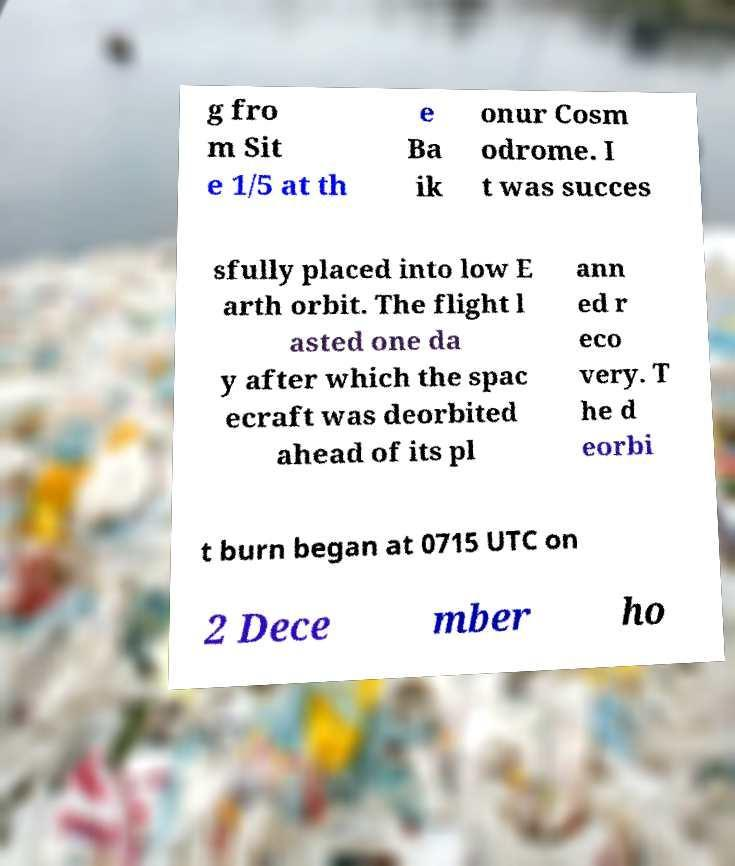Can you accurately transcribe the text from the provided image for me? g fro m Sit e 1/5 at th e Ba ik onur Cosm odrome. I t was succes sfully placed into low E arth orbit. The flight l asted one da y after which the spac ecraft was deorbited ahead of its pl ann ed r eco very. T he d eorbi t burn began at 0715 UTC on 2 Dece mber ho 